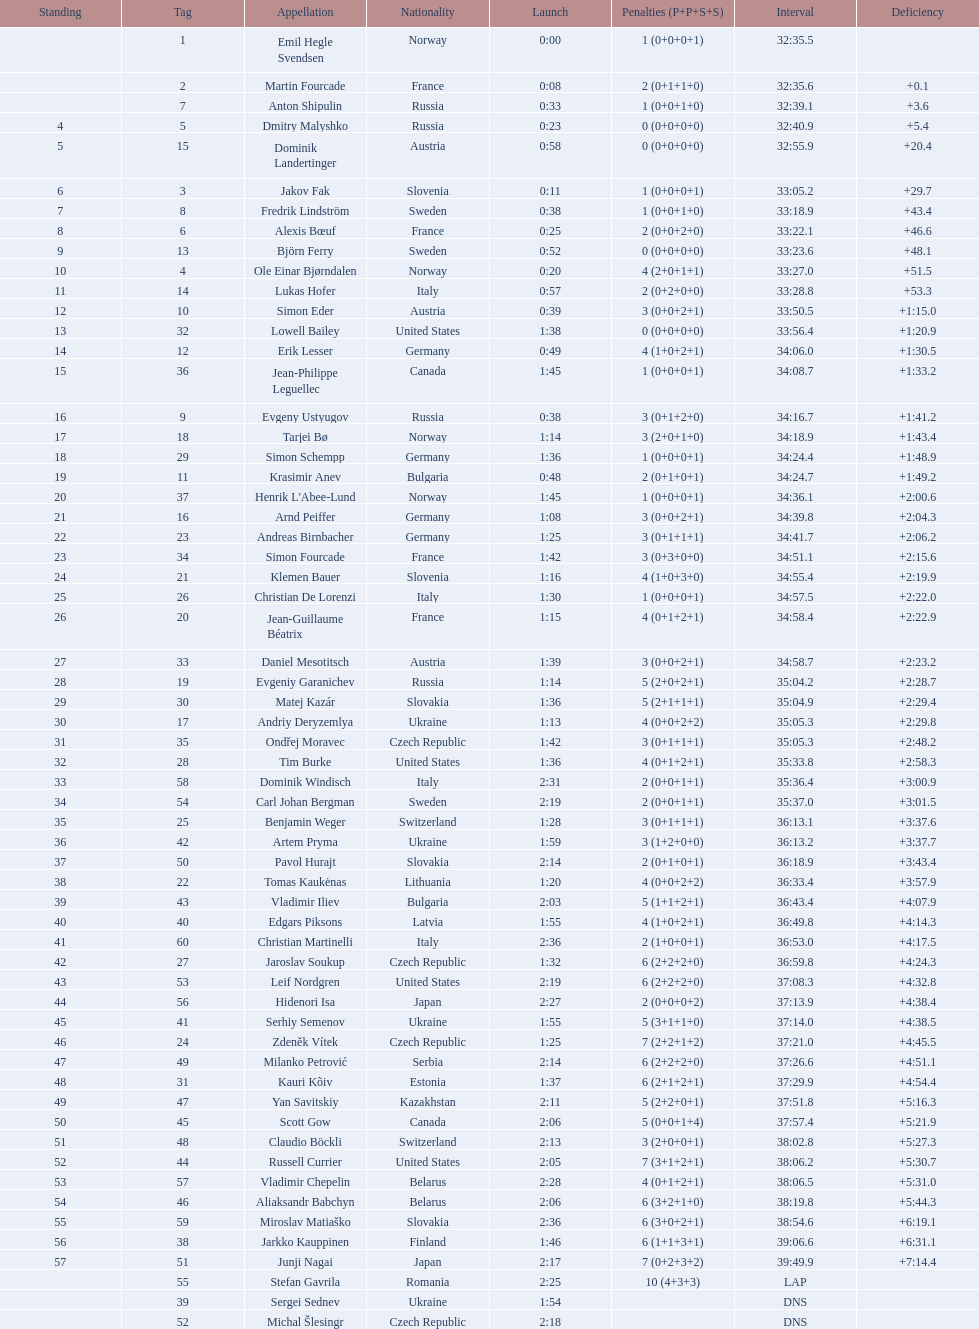What were the total number of "ties" (people who finished with the exact same time?) 2. 